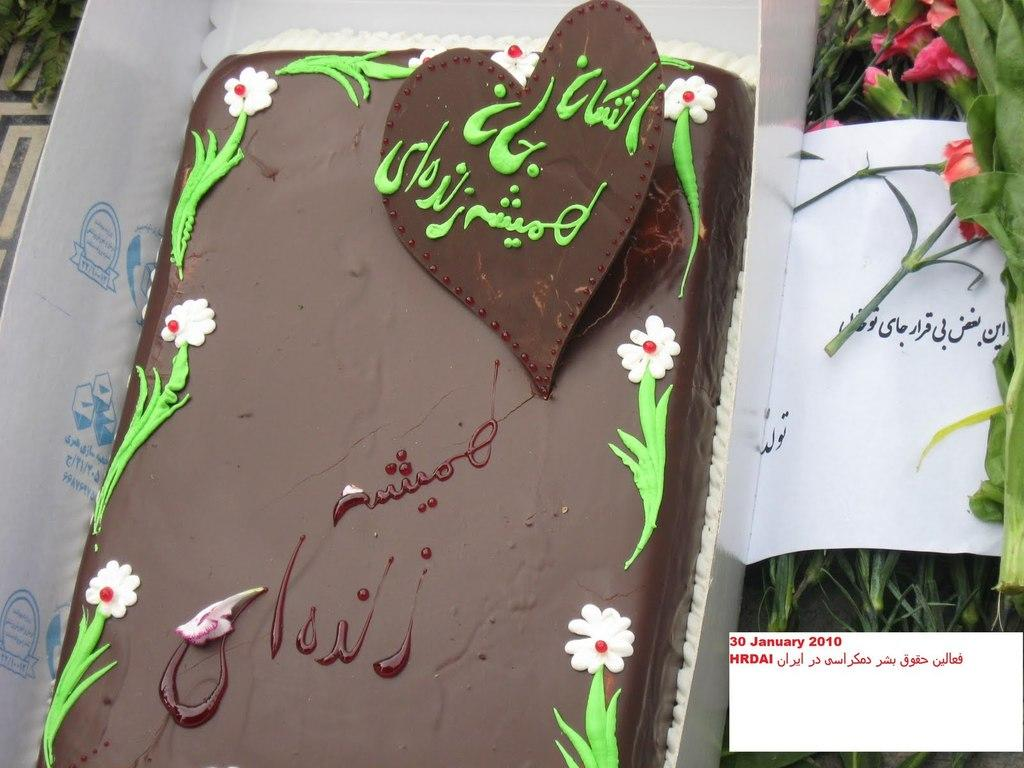What is the main subject of the image? There is a cake in the image. How is the cake being stored or transported? The cake is placed in a pastry box. What language is written on the paper in the image? The text on the paper is written in Urdu. What type of decorations or elements can be seen in the image? There are flowers and plants in the image. What thoughts are being discussed by the committee in the image? There is no committee or discussion of thoughts present in the image; it features a cake in a pastry box with flowers and plants. What type of string is used to tie the pastry box in the image? There is no string visible in the image; the pastry box is not tied with any string. 